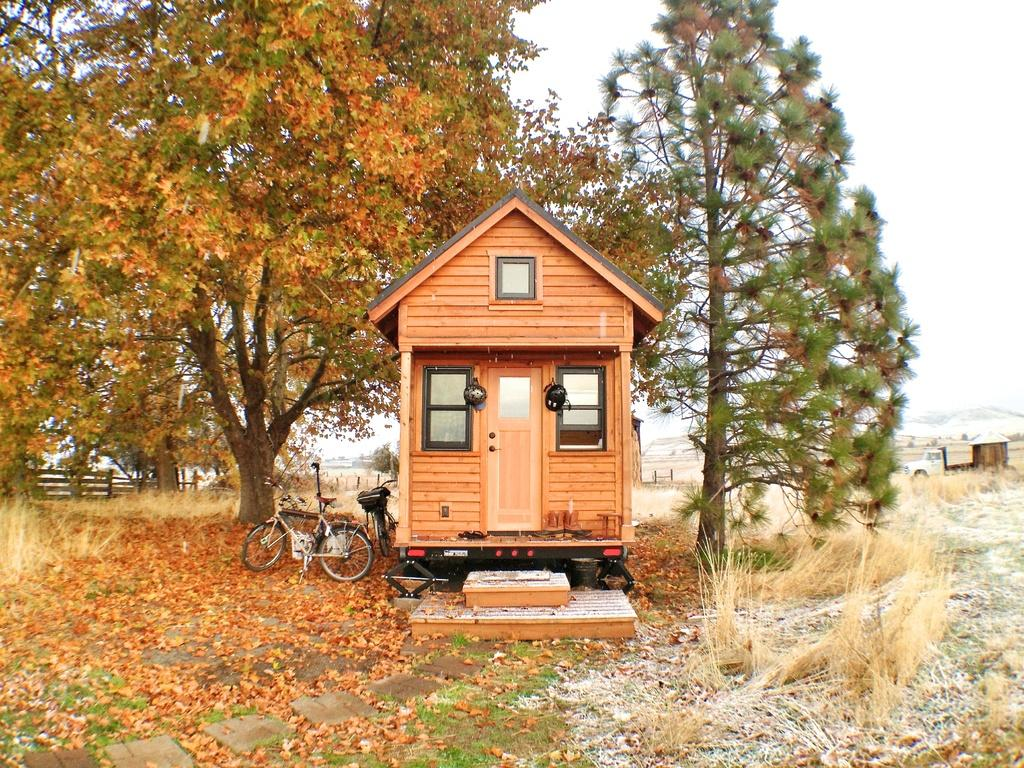What type of house is in the image? There is a wooden house in the image. What can be seen beside the wooden house? There are two cycles beside the wooden house. What is the surrounding environment of the house? There are trees around the house. What additional detail can be observed on the ground? Dry leaves are present in the image. What type of creature is holding the heart in the image? There is no creature or heart present in the image. 